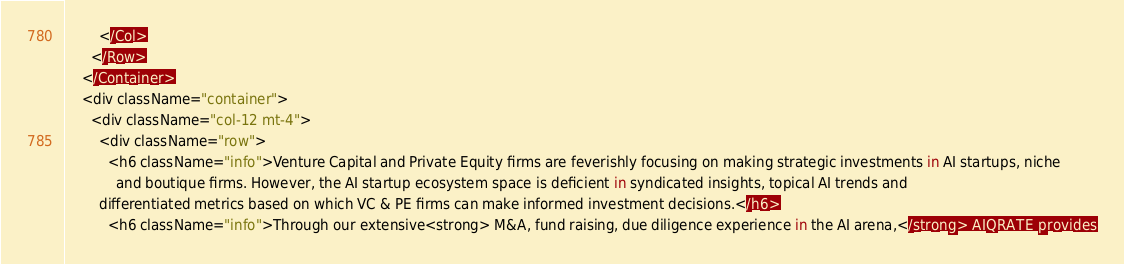<code> <loc_0><loc_0><loc_500><loc_500><_JavaScript_>        </Col>
      </Row>
    </Container>
    <div className="container">
      <div className="col-12 mt-4">
        <div className="row">
          <h6 className="info">Venture Capital and Private Equity firms are feverishly focusing on making strategic investments in AI startups, niche
            and boutique firms. However, the AI startup ecosystem space is deficient in syndicated insights, topical AI trends and
        differentiated metrics based on which VC & PE firms can make informed investment decisions.</h6>
          <h6 className="info">Through our extensive<strong> M&A, fund raising, due diligence experience in the AI arena,</strong> AIQRATE provides</code> 